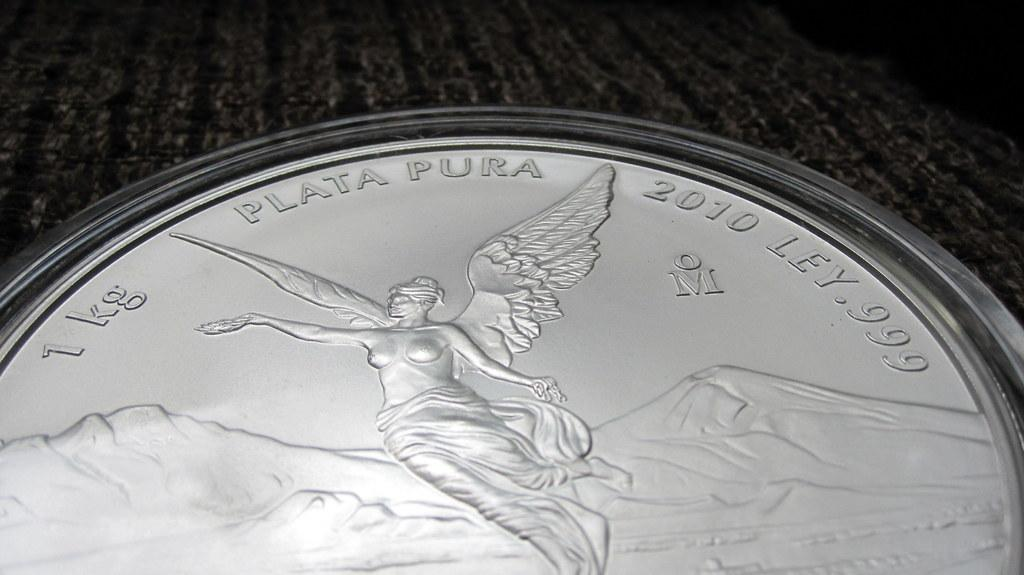Provide a one-sentence caption for the provided image. A 1kg Plata Pura coin featuring an angelic design is resting on a wooden surface. 